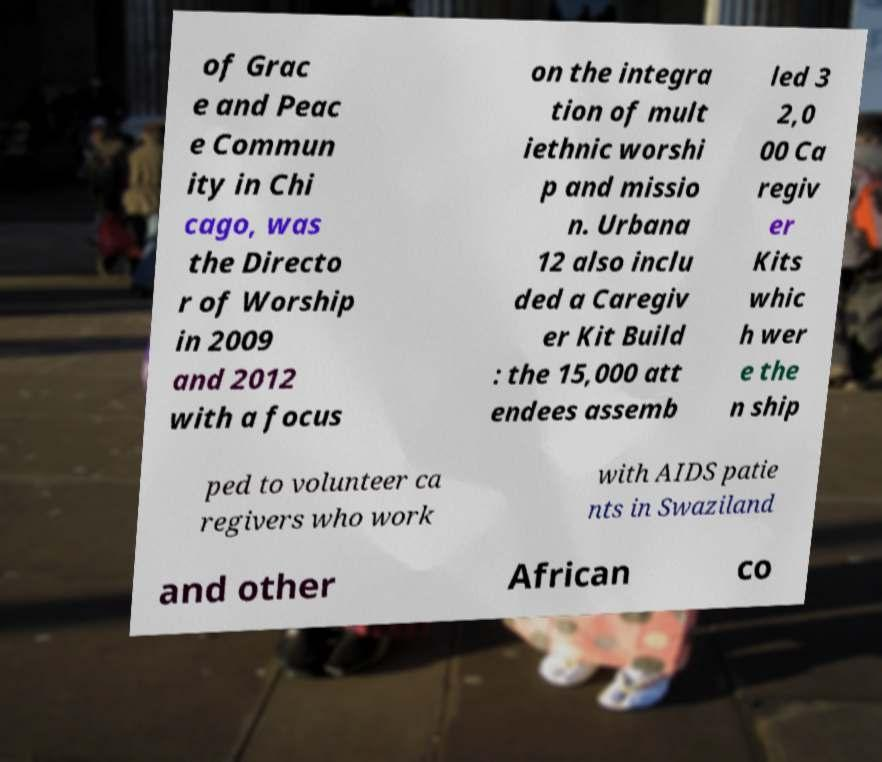Could you extract and type out the text from this image? of Grac e and Peac e Commun ity in Chi cago, was the Directo r of Worship in 2009 and 2012 with a focus on the integra tion of mult iethnic worshi p and missio n. Urbana 12 also inclu ded a Caregiv er Kit Build : the 15,000 att endees assemb led 3 2,0 00 Ca regiv er Kits whic h wer e the n ship ped to volunteer ca regivers who work with AIDS patie nts in Swaziland and other African co 